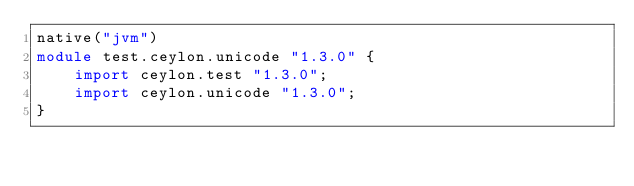<code> <loc_0><loc_0><loc_500><loc_500><_Ceylon_>native("jvm")
module test.ceylon.unicode "1.3.0" {
    import ceylon.test "1.3.0";
    import ceylon.unicode "1.3.0";
}
</code> 